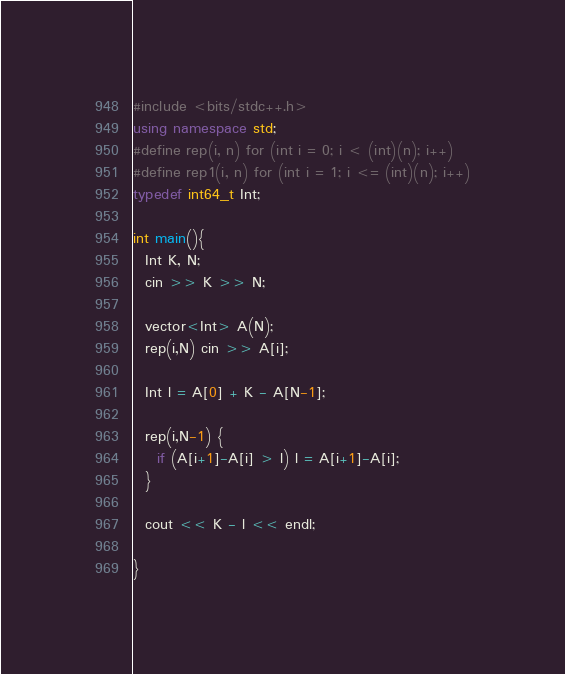Convert code to text. <code><loc_0><loc_0><loc_500><loc_500><_C++_>#include <bits/stdc++.h>
using namespace std;
#define rep(i, n) for (int i = 0; i < (int)(n); i++)
#define rep1(i, n) for (int i = 1; i <= (int)(n); i++)
typedef int64_t Int;

int main(){ 
  Int K, N;
  cin >> K >> N;
  
  vector<Int> A(N);
  rep(i,N) cin >> A[i];
  
  Int l = A[0] + K - A[N-1];
  
  rep(i,N-1) {
    if (A[i+1]-A[i] > l) l = A[i+1]-A[i];
  }
  
  cout << K - l << endl;

}</code> 